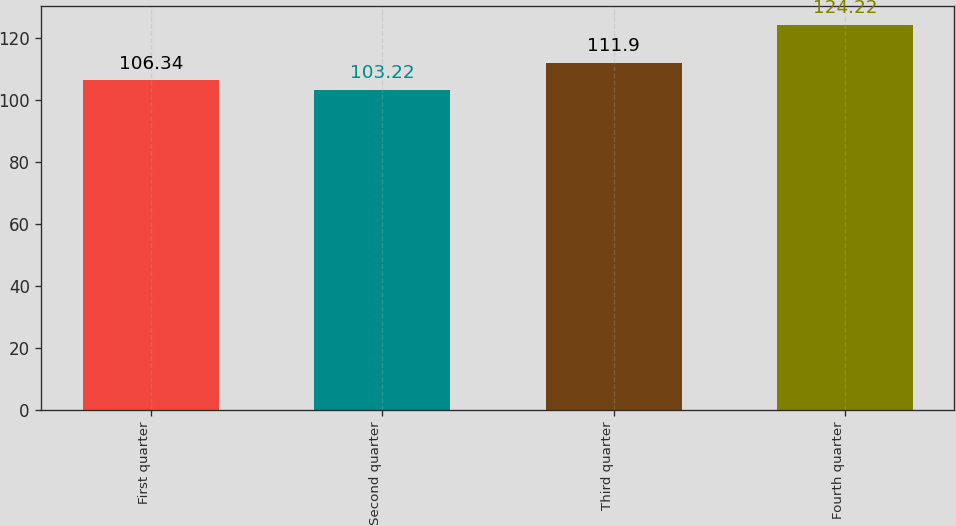Convert chart to OTSL. <chart><loc_0><loc_0><loc_500><loc_500><bar_chart><fcel>First quarter<fcel>Second quarter<fcel>Third quarter<fcel>Fourth quarter<nl><fcel>106.34<fcel>103.22<fcel>111.9<fcel>124.22<nl></chart> 